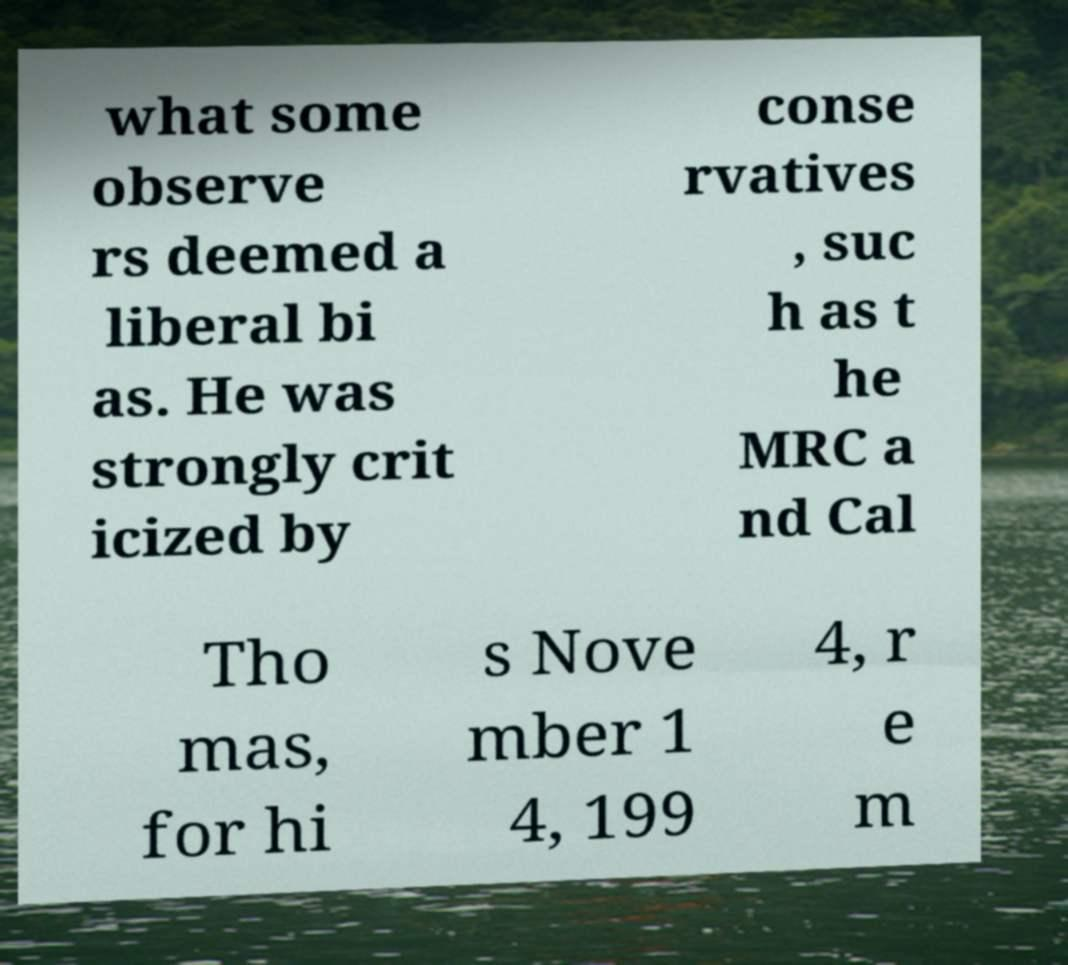What messages or text are displayed in this image? I need them in a readable, typed format. what some observe rs deemed a liberal bi as. He was strongly crit icized by conse rvatives , suc h as t he MRC a nd Cal Tho mas, for hi s Nove mber 1 4, 199 4, r e m 